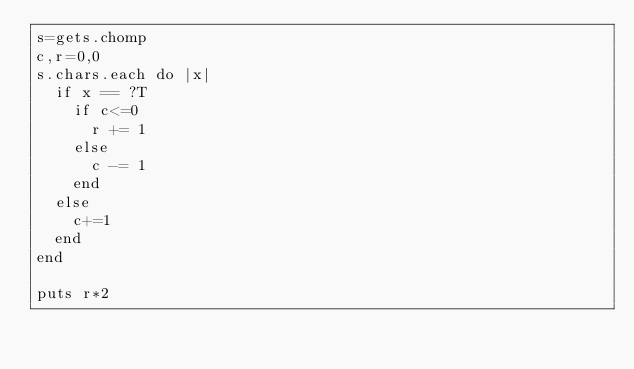Convert code to text. <code><loc_0><loc_0><loc_500><loc_500><_Ruby_>s=gets.chomp
c,r=0,0
s.chars.each do |x|
  if x == ?T 
    if c<=0
      r += 1
    else
      c -= 1
    end
  else
    c+=1
  end
end

puts r*2</code> 